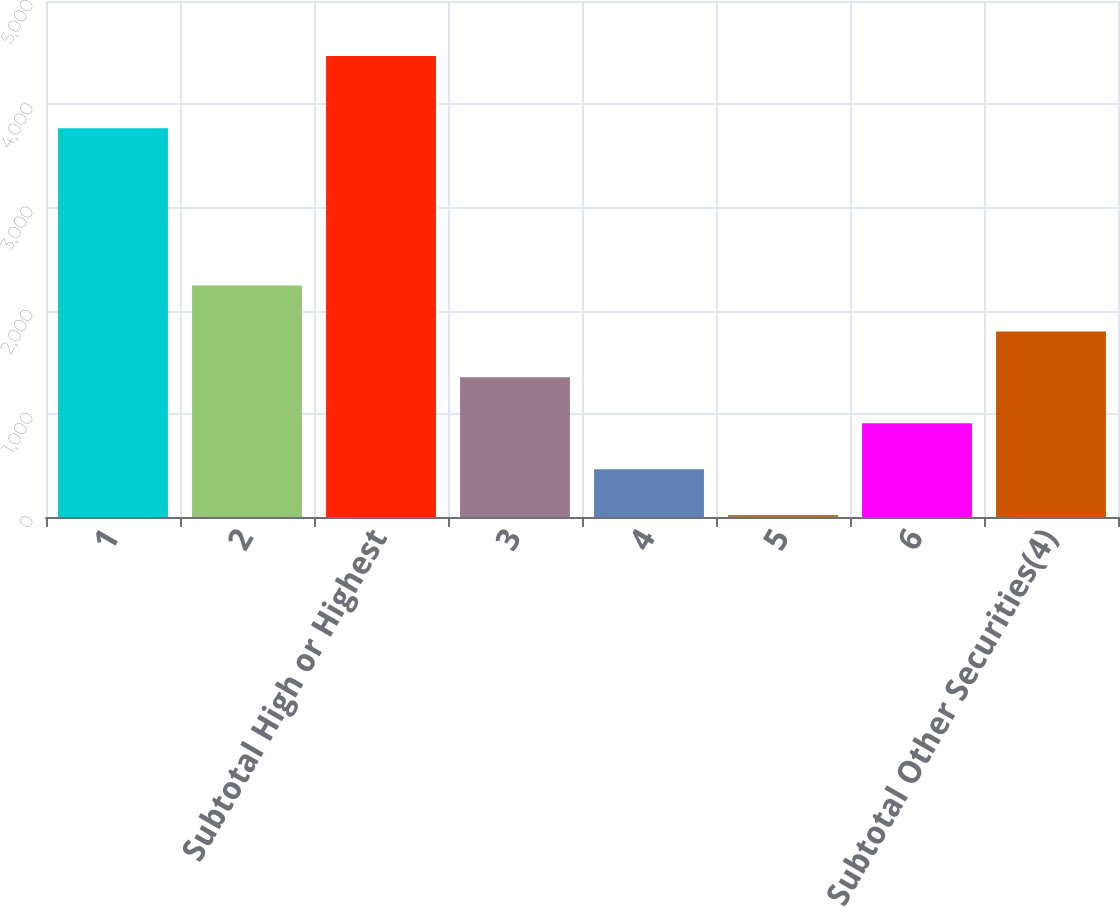<chart> <loc_0><loc_0><loc_500><loc_500><bar_chart><fcel>1<fcel>2<fcel>Subtotal High or Highest<fcel>3<fcel>4<fcel>5<fcel>6<fcel>Subtotal Other Securities(4)<nl><fcel>3767<fcel>2242.5<fcel>4466<fcel>1353.1<fcel>463.7<fcel>19<fcel>908.4<fcel>1797.8<nl></chart> 